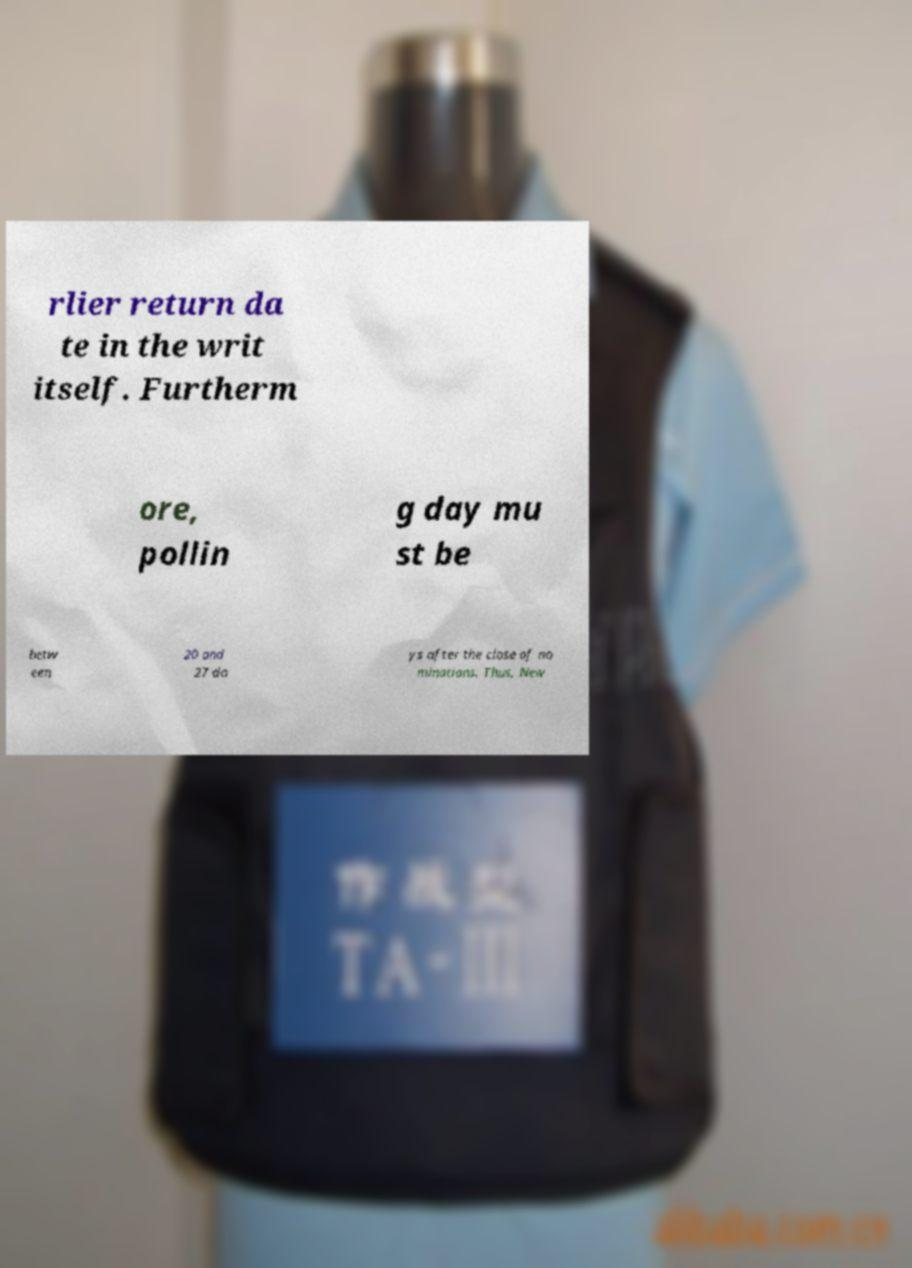Can you read and provide the text displayed in the image?This photo seems to have some interesting text. Can you extract and type it out for me? rlier return da te in the writ itself. Furtherm ore, pollin g day mu st be betw een 20 and 27 da ys after the close of no minations. Thus, New 